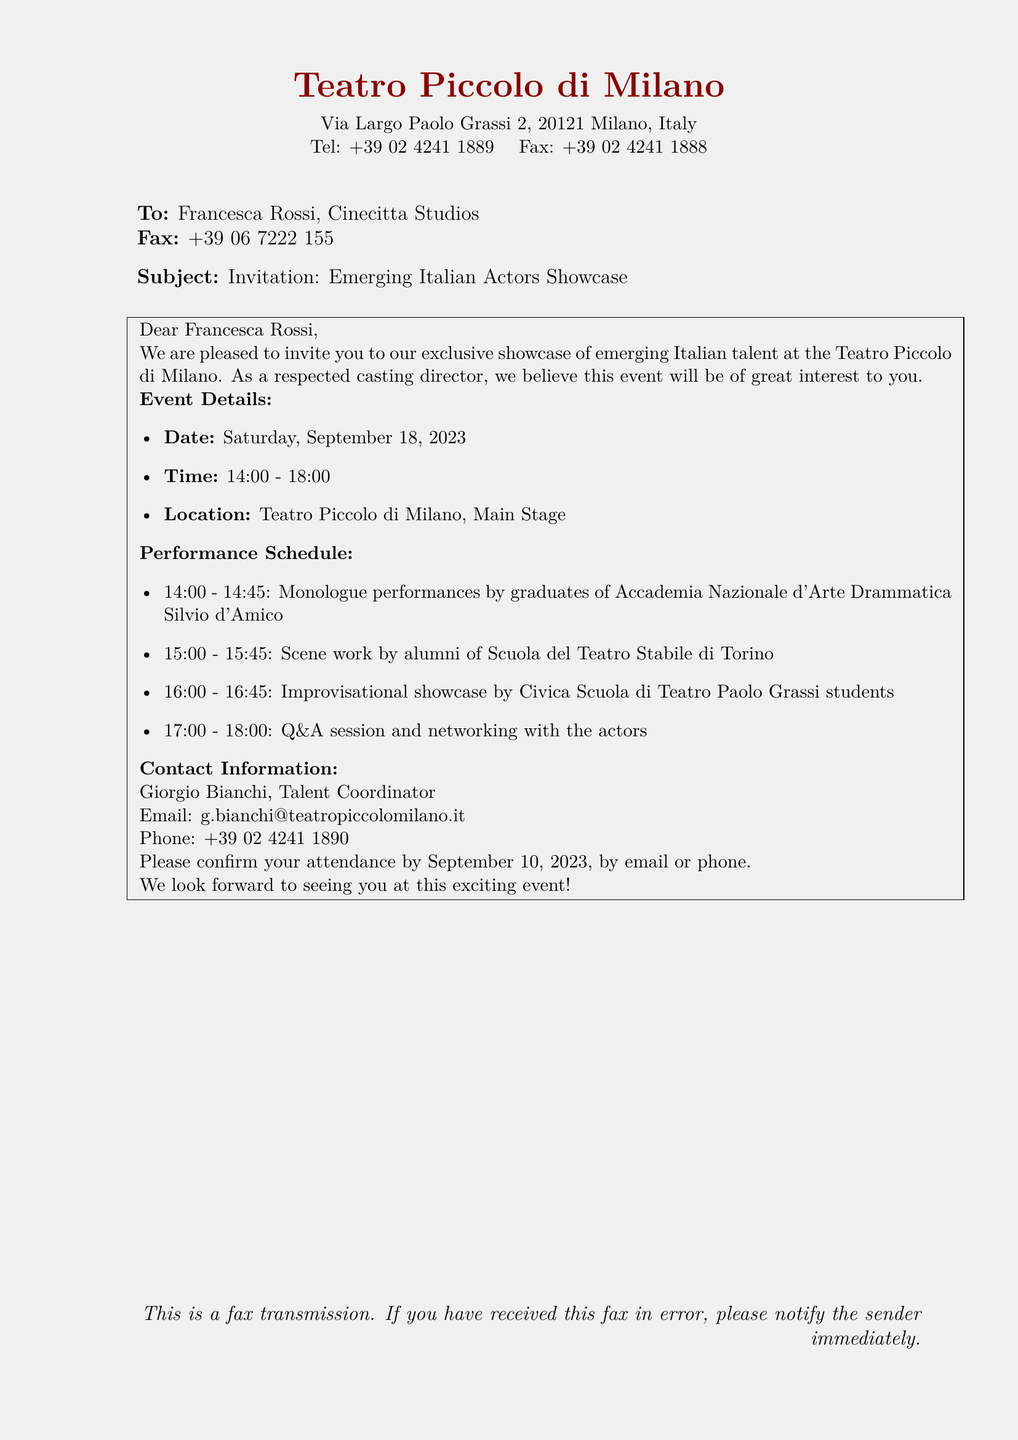What is the location of the event? The location of the event is found in the document, which specifies it as Teatro Piccolo di Milano.
Answer: Teatro Piccolo di Milano What is the date of the showcase? The date is explicitly stated in the event details section of the document as Saturday, September 18, 2023.
Answer: Saturday, September 18, 2023 Who is the contact person for the event? The document provides the name of the contact person, identified as Giorgio Bianchi, Talent Coordinator.
Answer: Giorgio Bianchi What time does the showcase start? The starting time is given in the event details, which indicates that the showcase begins at 14:00.
Answer: 14:00 What is the last time to confirm attendance? The last date to confirm attendance is mentioned in the document as September 10, 2023.
Answer: September 10, 2023 What type of performances are included in the schedule? The performance schedule lists various types of performances such as monologues, scene work, and improvisational showcase.
Answer: Monologue, Scene work, Improvisational showcase What is the duration of the Q&A session? The document specifies that the Q&A session lasts for one hour, from 17:00 to 18:00.
Answer: 1 hour What is the fax number for Cinecitta Studios? The fax number for Cinecitta Studios is provided as +39 06 7222 155.
Answer: +39 06 7222 155 